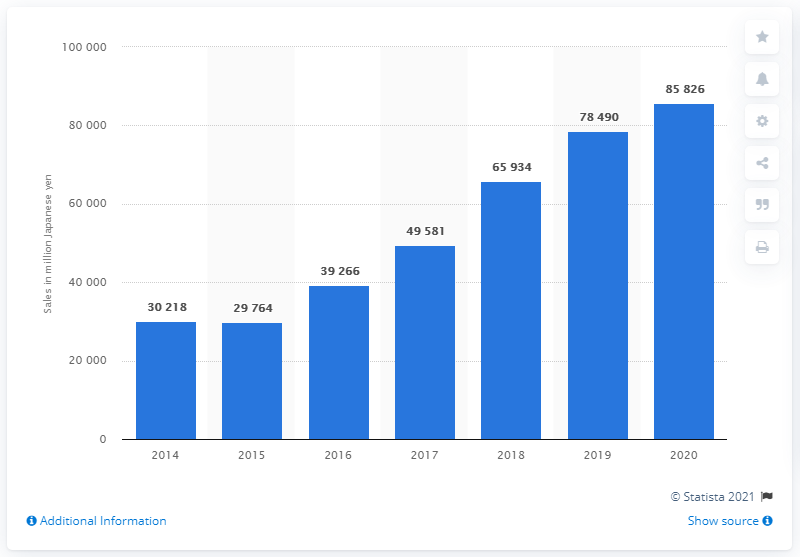Specify some key components in this picture. The global market for ADAS ultrasonic wave components is projected to reach approximately 858,260 yen by 2020. 